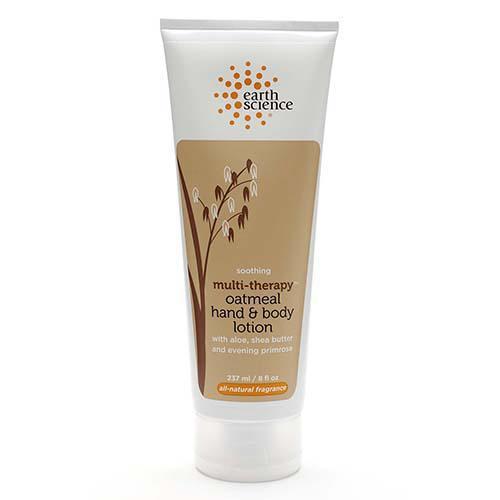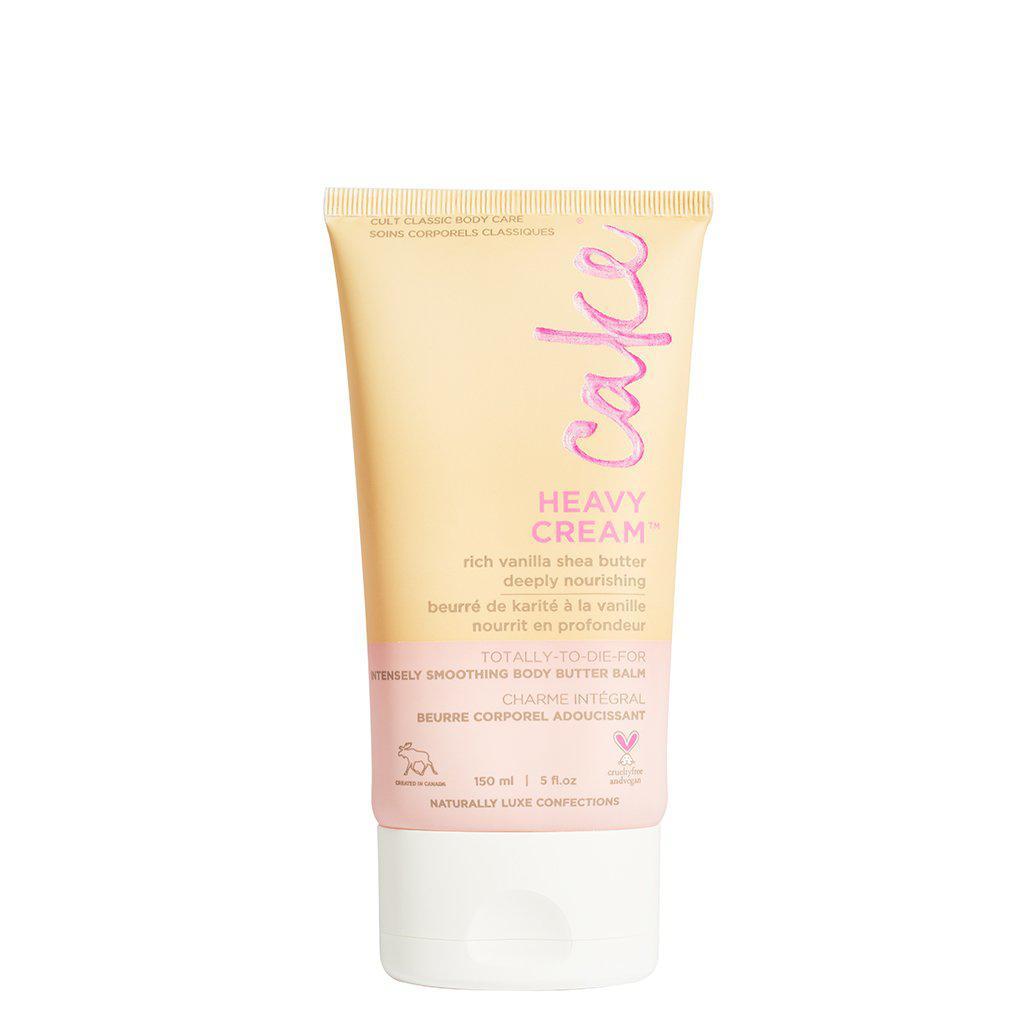The first image is the image on the left, the second image is the image on the right. For the images displayed, is the sentence "The left and right image contains the same number of closed lotion bottles." factually correct? Answer yes or no. Yes. The first image is the image on the left, the second image is the image on the right. Analyze the images presented: Is the assertion "One image shows the finger of one hand pressing the top of a white bottle to squirt lotion on another hand." valid? Answer yes or no. No. 